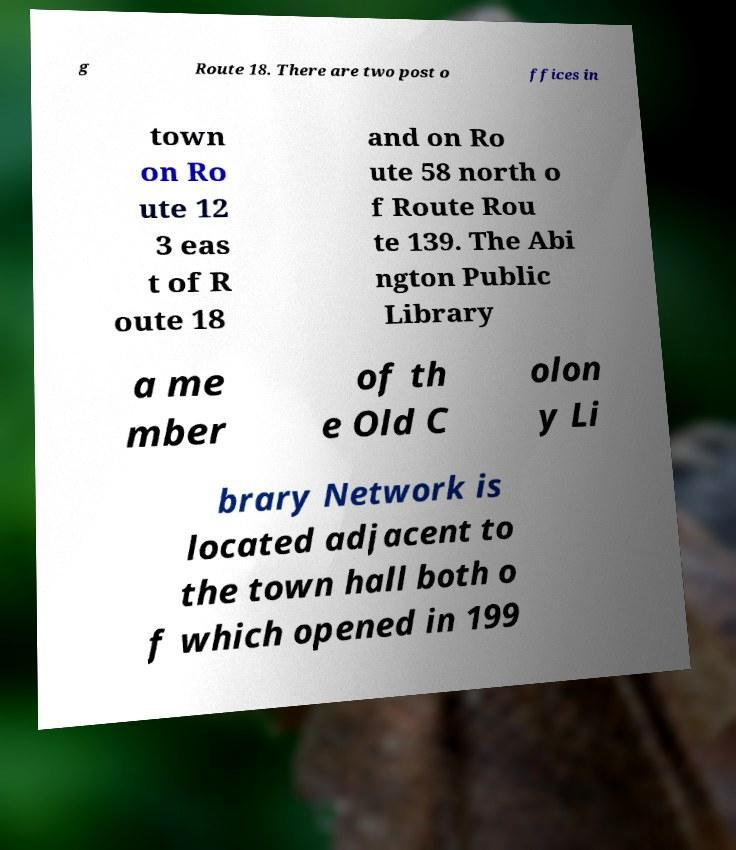For documentation purposes, I need the text within this image transcribed. Could you provide that? g Route 18. There are two post o ffices in town on Ro ute 12 3 eas t of R oute 18 and on Ro ute 58 north o f Route Rou te 139. The Abi ngton Public Library a me mber of th e Old C olon y Li brary Network is located adjacent to the town hall both o f which opened in 199 